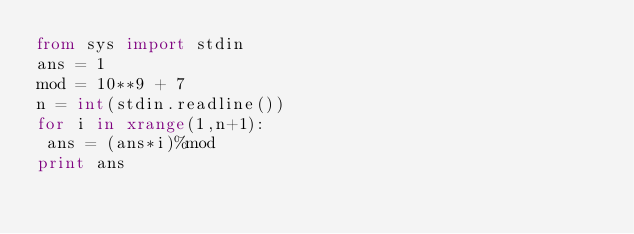<code> <loc_0><loc_0><loc_500><loc_500><_Python_>from sys import stdin
ans = 1
mod = 10**9 + 7
n = int(stdin.readline())
for i in xrange(1,n+1):
 ans = (ans*i)%mod
print ans</code> 